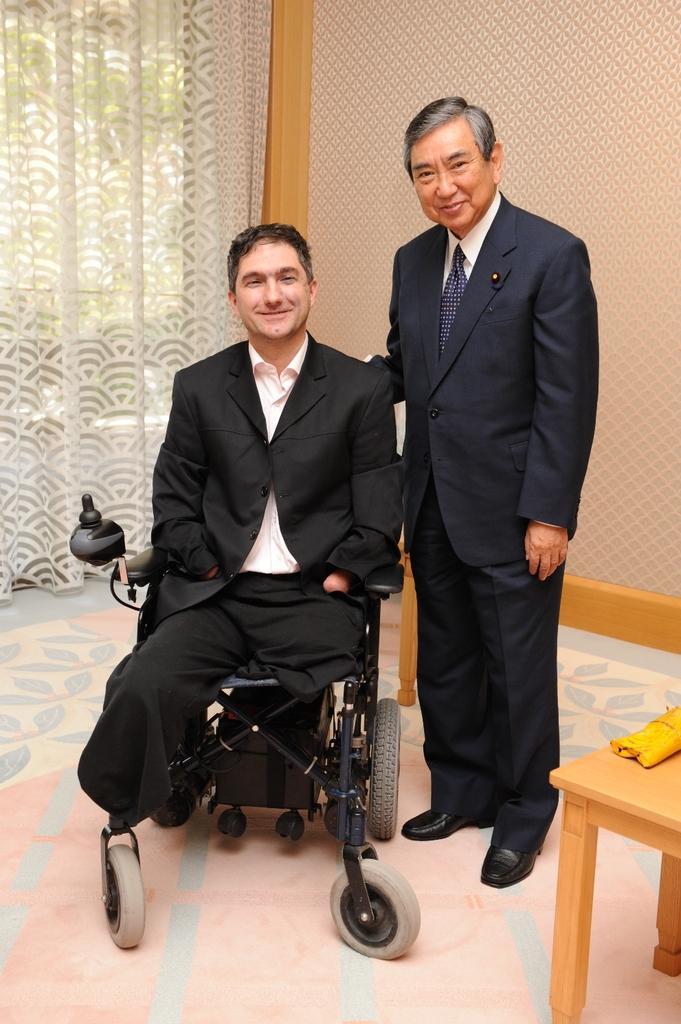Could you give a brief overview of what you see in this image? The person who is disabled is sitting in a wheel chair and there is another person standing beside him and there is a white curtain in the background. 